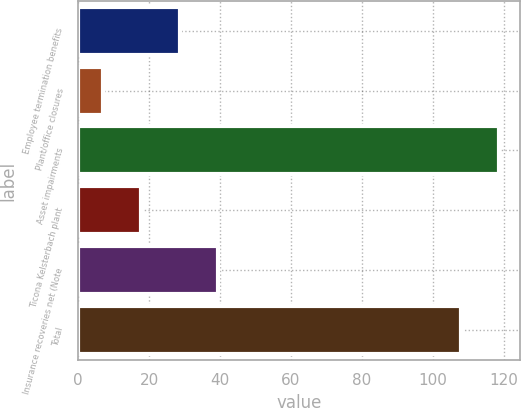Convert chart to OTSL. <chart><loc_0><loc_0><loc_500><loc_500><bar_chart><fcel>Employee termination benefits<fcel>Plant/office closures<fcel>Asset impairments<fcel>Ticona Kelsterbach plant<fcel>Insurance recoveries net (Note<fcel>Total<nl><fcel>28.6<fcel>7<fcel>118.8<fcel>17.8<fcel>39.4<fcel>108<nl></chart> 